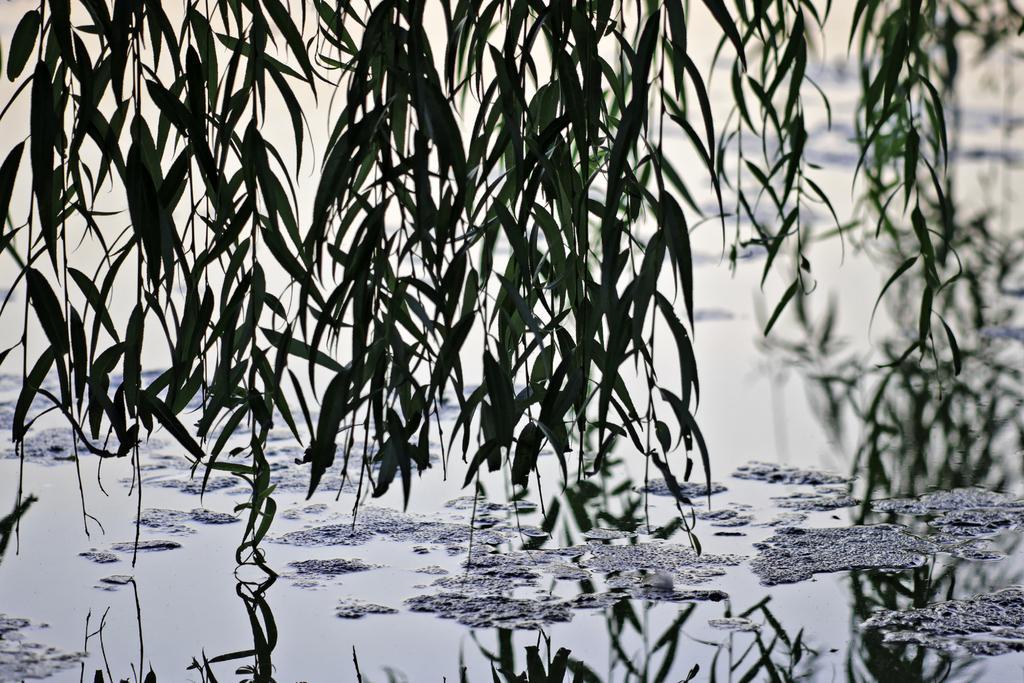Could you give a brief overview of what you see in this image? As we can see in the image there are plants and water. The background is blurred. 